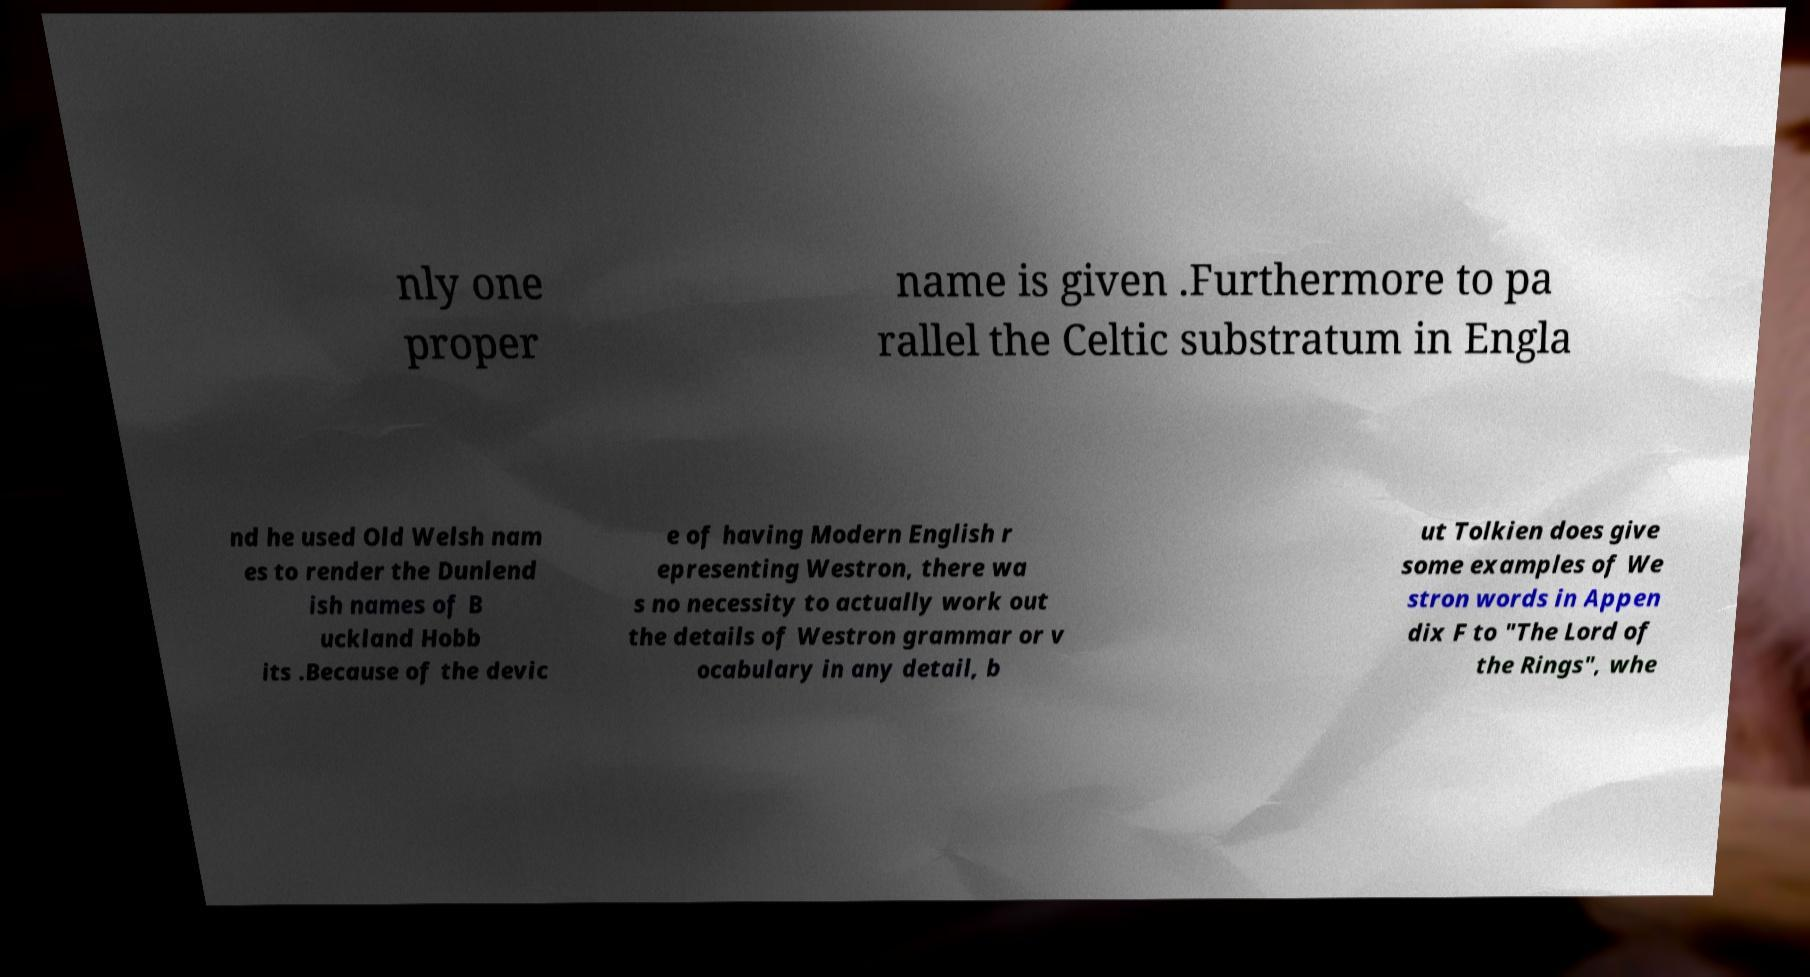Can you accurately transcribe the text from the provided image for me? nly one proper name is given .Furthermore to pa rallel the Celtic substratum in Engla nd he used Old Welsh nam es to render the Dunlend ish names of B uckland Hobb its .Because of the devic e of having Modern English r epresenting Westron, there wa s no necessity to actually work out the details of Westron grammar or v ocabulary in any detail, b ut Tolkien does give some examples of We stron words in Appen dix F to "The Lord of the Rings", whe 